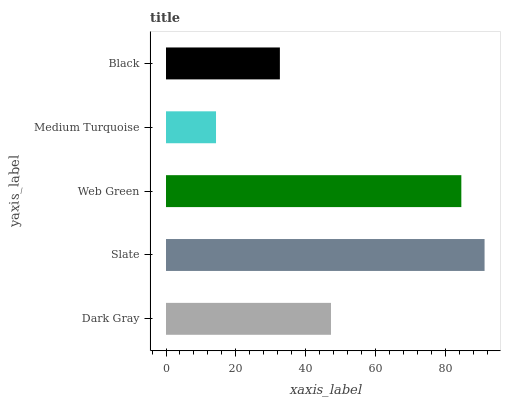Is Medium Turquoise the minimum?
Answer yes or no. Yes. Is Slate the maximum?
Answer yes or no. Yes. Is Web Green the minimum?
Answer yes or no. No. Is Web Green the maximum?
Answer yes or no. No. Is Slate greater than Web Green?
Answer yes or no. Yes. Is Web Green less than Slate?
Answer yes or no. Yes. Is Web Green greater than Slate?
Answer yes or no. No. Is Slate less than Web Green?
Answer yes or no. No. Is Dark Gray the high median?
Answer yes or no. Yes. Is Dark Gray the low median?
Answer yes or no. Yes. Is Medium Turquoise the high median?
Answer yes or no. No. Is Web Green the low median?
Answer yes or no. No. 